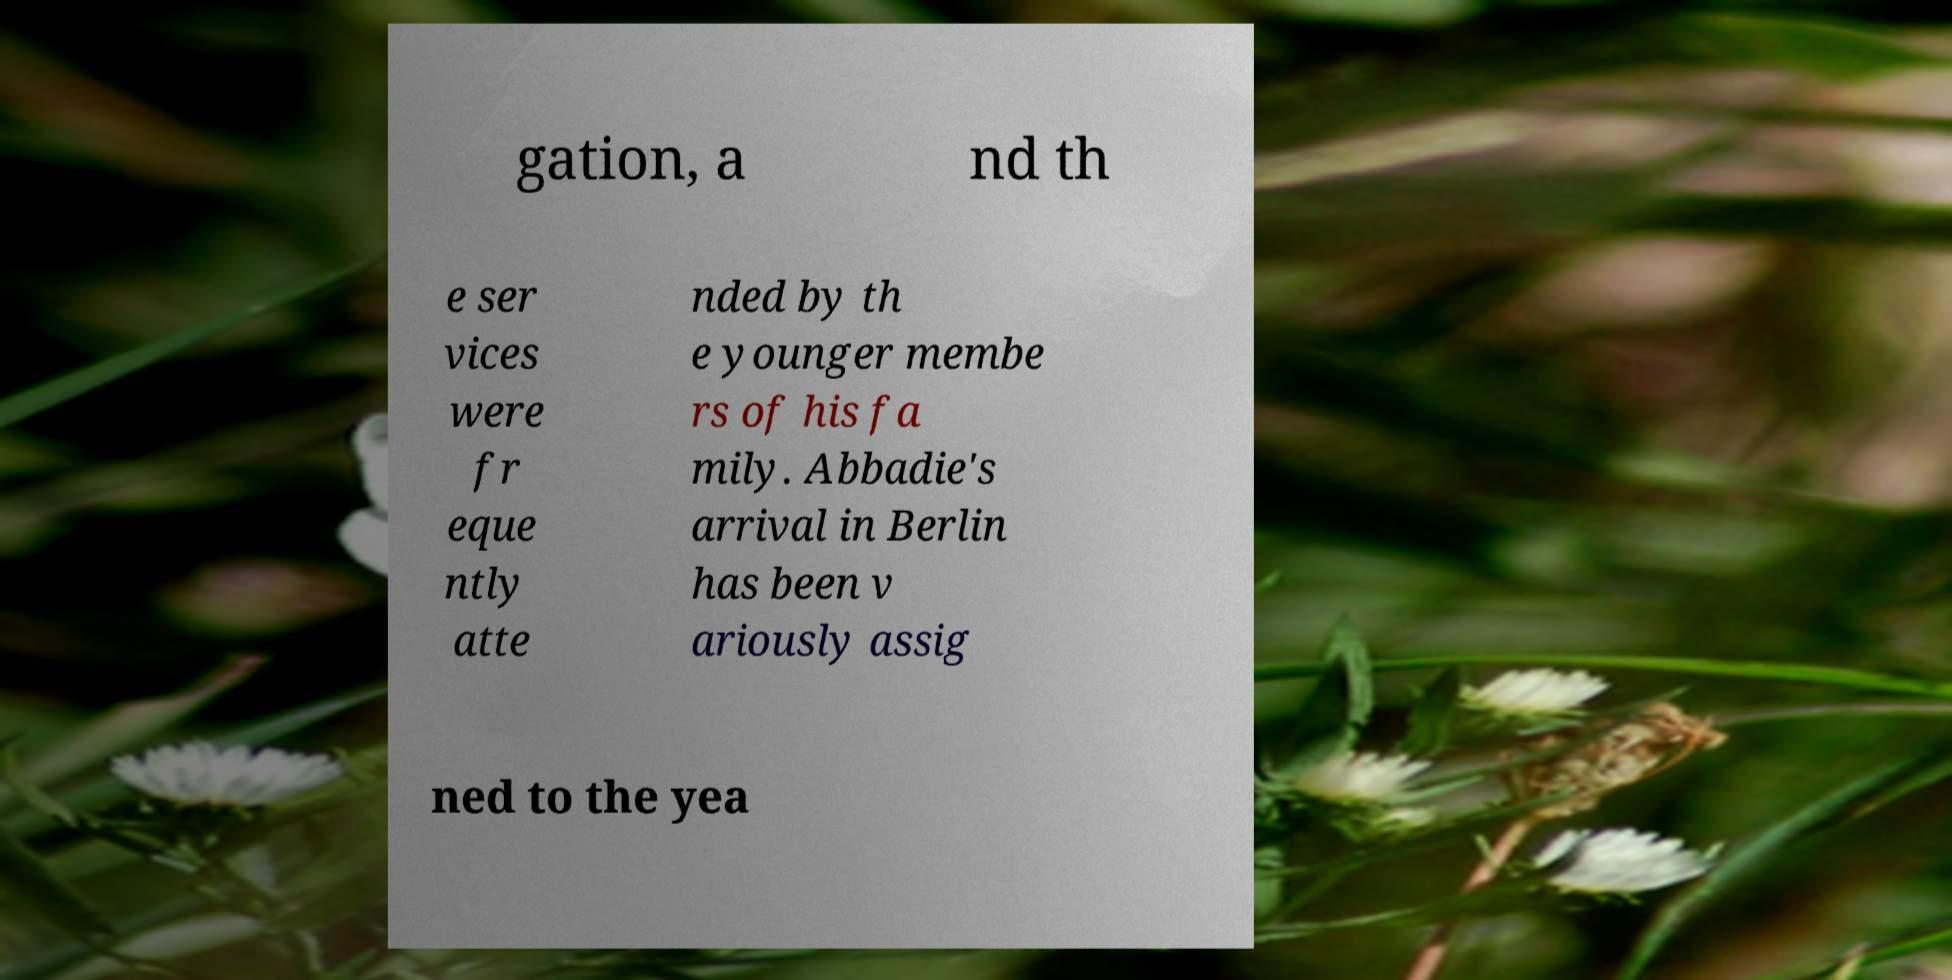Can you accurately transcribe the text from the provided image for me? gation, a nd th e ser vices were fr eque ntly atte nded by th e younger membe rs of his fa mily. Abbadie's arrival in Berlin has been v ariously assig ned to the yea 